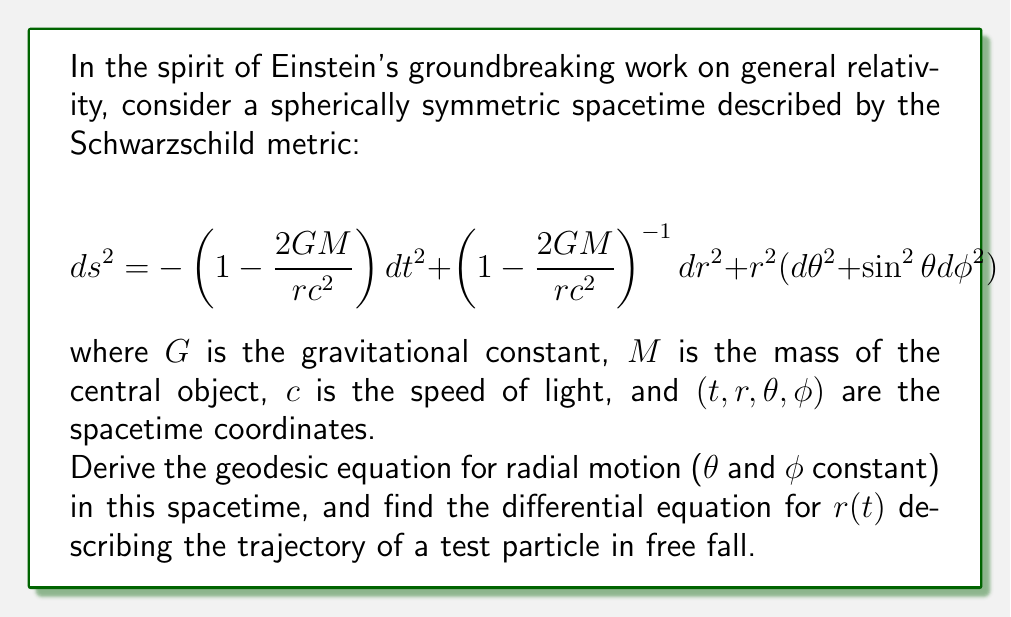Can you solve this math problem? Let's approach this problem step-by-step, as Einstein would have done:

1) First, we need to derive the Lagrangian for radial motion. In this case, $\theta$ and $\phi$ are constant, so:

   $$ L = -mc^2\sqrt{1-\frac{ds^2}{c^2dt^2}} = -mc^2\sqrt{1-\left(1-\frac{2GM}{rc^2}\right)-\left(1-\frac{2GM}{rc^2}\right)^{-1}\left(\frac{dr}{dt}\right)^2} $$

2) The Euler-Lagrange equation for this system is:

   $$ \frac{d}{dt}\left(\frac{\partial L}{\partial \dot{r}}\right) - \frac{\partial L}{\partial r} = 0 $$

3) Let's define $f(r) = 1-\frac{2GM}{rc^2}$ for simplicity. Then:

   $$ \frac{\partial L}{\partial \dot{r}} = \frac{mc^2\dot{r}}{f(r)\sqrt{f(r)-\frac{\dot{r}^2}{f(r)}}} $$

   $$ \frac{\partial L}{\partial r} = -\frac{mc^2}{2\sqrt{f(r)-\frac{\dot{r}^2}{f(r)}}}\left(f'(r)+\frac{\dot{r}^2f'(r)}{f(r)^2}\right) $$

4) Substituting these into the Euler-Lagrange equation and simplifying:

   $$ \ddot{r} + \frac{GM}{r^2} - \frac{3GM\dot{r}^2}{c^2r^2} = 0 $$

5) This is the geodesic equation for radial motion in Schwarzschild spacetime. To find $r(t)$, we need to solve this differential equation.

6) We can rewrite this as a system of first-order differential equations:

   $$ \frac{dr}{dt} = v $$
   $$ \frac{dv}{dt} = -\frac{GM}{r^2} + \frac{3GMv^2}{c^2r^2} $$

This system of equations describes the trajectory $r(t)$ of a test particle in free fall in Schwarzschild spacetime.
Answer: $\frac{dr}{dt} = v$, $\frac{dv}{dt} = -\frac{GM}{r^2} + \frac{3GMv^2}{c^2r^2}$ 